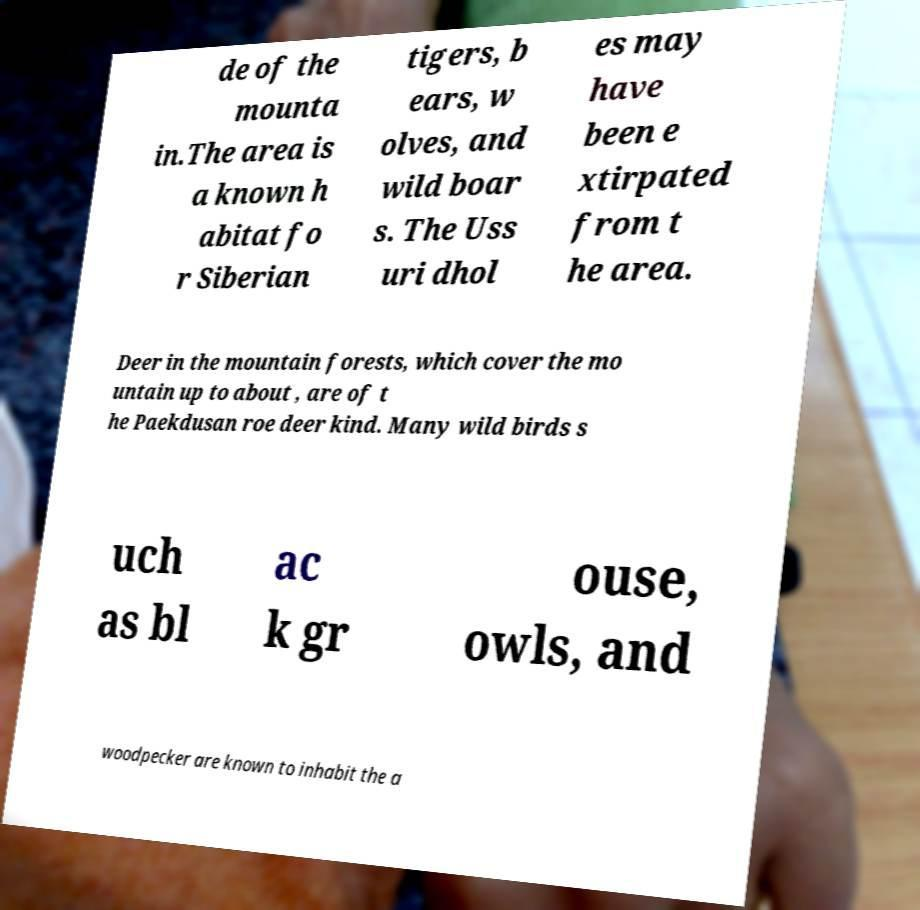Could you assist in decoding the text presented in this image and type it out clearly? de of the mounta in.The area is a known h abitat fo r Siberian tigers, b ears, w olves, and wild boar s. The Uss uri dhol es may have been e xtirpated from t he area. Deer in the mountain forests, which cover the mo untain up to about , are of t he Paekdusan roe deer kind. Many wild birds s uch as bl ac k gr ouse, owls, and woodpecker are known to inhabit the a 